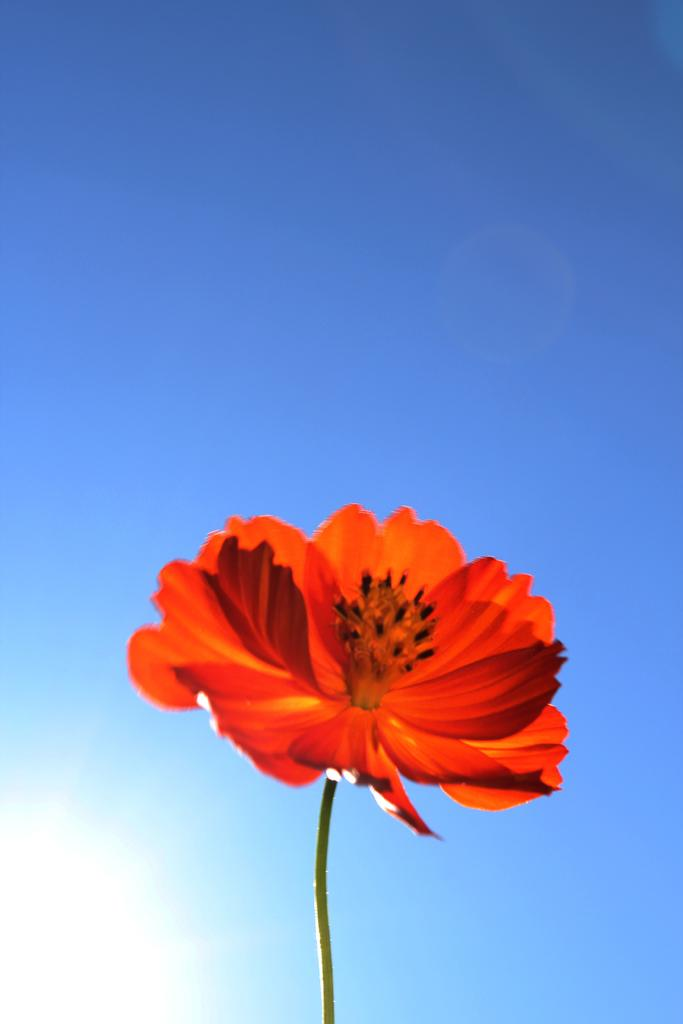What is the main subject of the image? There is a flower in the center of the image. Can you describe the flower in the image? The flower appears to be in full bloom, with petals of a certain color and shape. What might be the significance of the flower in the image? The flower could symbolize beauty, growth, or nature, depending on the context. What type of humor can be seen in the image? There is no humor present in the image, as it features a flower in the center. Can you tell me who provided the credit for the flower in the image? There is no reference to credit or authorship in the image, as it simply depicts a flower. 